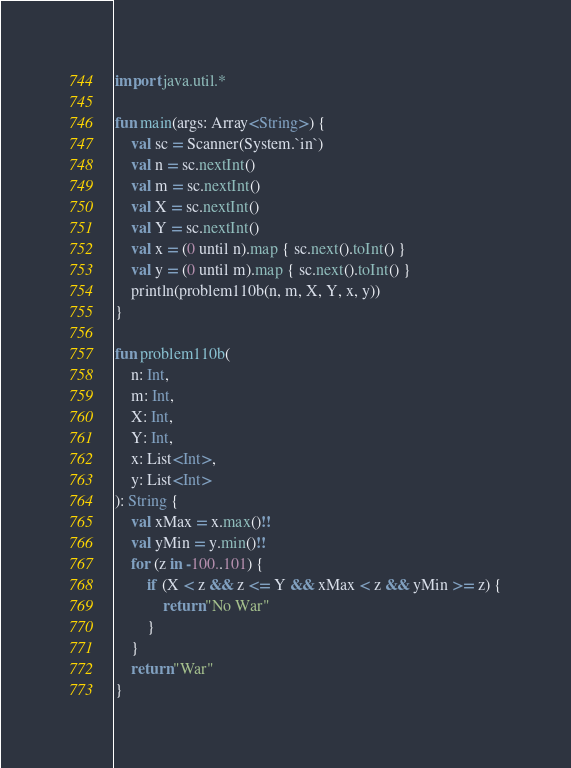Convert code to text. <code><loc_0><loc_0><loc_500><loc_500><_Kotlin_>import java.util.*

fun main(args: Array<String>) {
    val sc = Scanner(System.`in`)
    val n = sc.nextInt()
    val m = sc.nextInt()
    val X = sc.nextInt()
    val Y = sc.nextInt()
    val x = (0 until n).map { sc.next().toInt() }
    val y = (0 until m).map { sc.next().toInt() }
    println(problem110b(n, m, X, Y, x, y))
}

fun problem110b(
    n: Int,
    m: Int,
    X: Int,
    Y: Int,
    x: List<Int>,
    y: List<Int>
): String {
    val xMax = x.max()!!
    val yMin = y.min()!!
    for (z in -100..101) {
        if (X < z && z <= Y && xMax < z && yMin >= z) {
            return "No War"
        }
    }
    return "War"
}</code> 